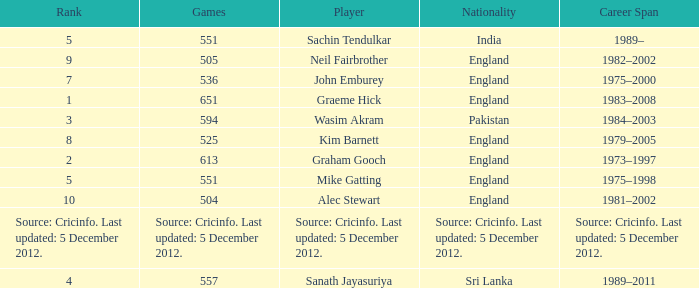What is the country of origin for the player who took part in 505 games? England. 